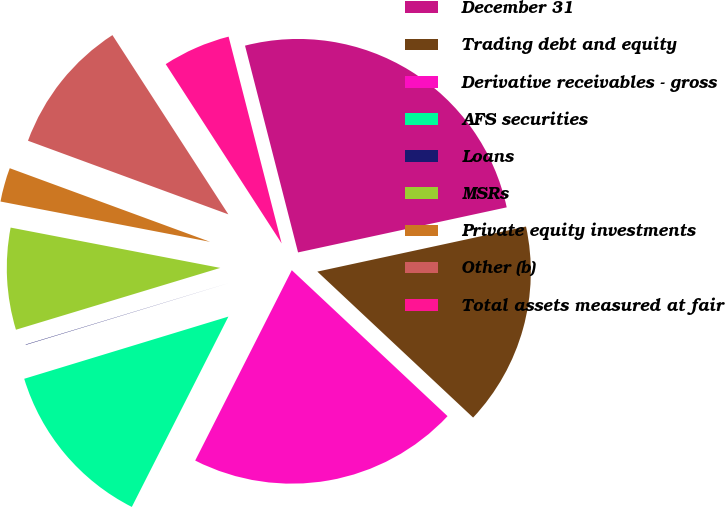<chart> <loc_0><loc_0><loc_500><loc_500><pie_chart><fcel>December 31<fcel>Trading debt and equity<fcel>Derivative receivables - gross<fcel>AFS securities<fcel>Loans<fcel>MSRs<fcel>Private equity investments<fcel>Other (b)<fcel>Total assets measured at fair<nl><fcel>25.61%<fcel>15.37%<fcel>20.49%<fcel>12.82%<fcel>0.03%<fcel>7.7%<fcel>2.58%<fcel>10.26%<fcel>5.14%<nl></chart> 